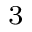<formula> <loc_0><loc_0><loc_500><loc_500>_ { 3 }</formula> 